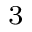<formula> <loc_0><loc_0><loc_500><loc_500>_ { 3 }</formula> 